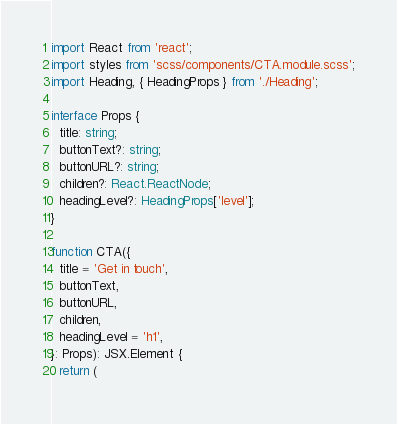<code> <loc_0><loc_0><loc_500><loc_500><_TypeScript_>import React from 'react';
import styles from 'scss/components/CTA.module.scss';
import Heading, { HeadingProps } from './Heading';

interface Props {
  title: string;
  buttonText?: string;
  buttonURL?: string;
  children?: React.ReactNode;
  headingLevel?: HeadingProps['level'];
}

function CTA({
  title = 'Get in touch',
  buttonText,
  buttonURL,
  children,
  headingLevel = 'h1',
}: Props): JSX.Element {
  return (</code> 